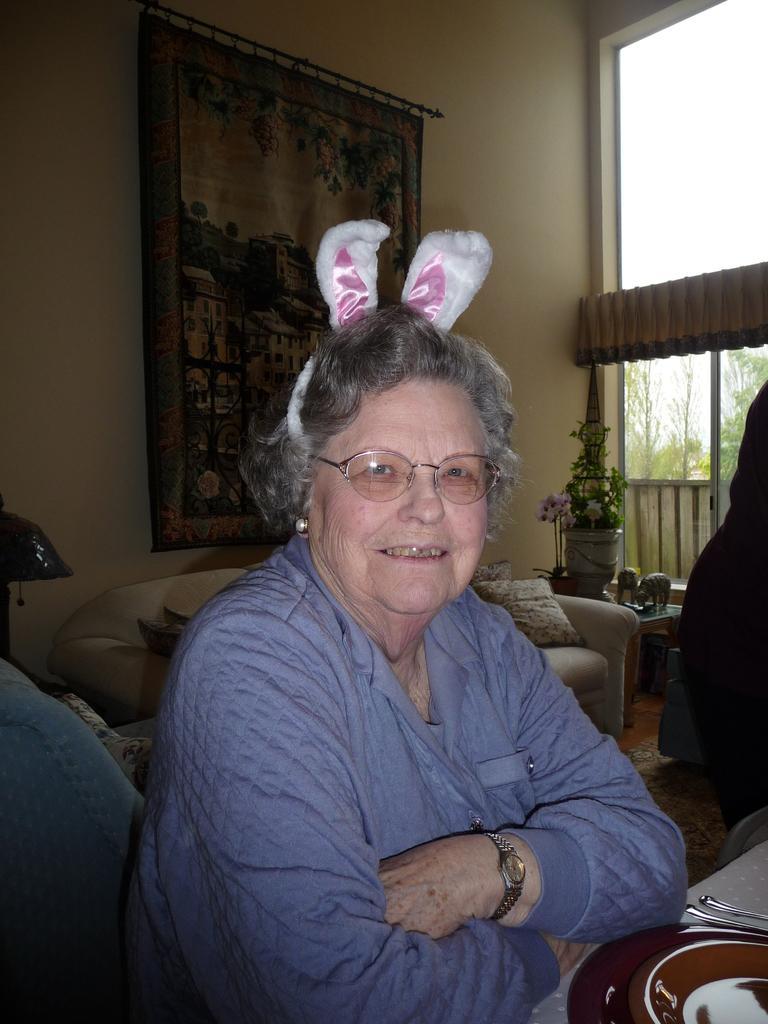Can you describe this image briefly? The image is inside the room. In the image there is a woman sitting on chair in front of a table. On table we can see spoons,bowl,plate,cloth on right side we can also another table on which it is having plant,flowers and flower pot. On left side there is a wall and painting, in background there are some trees,glass door and sky is on top. 